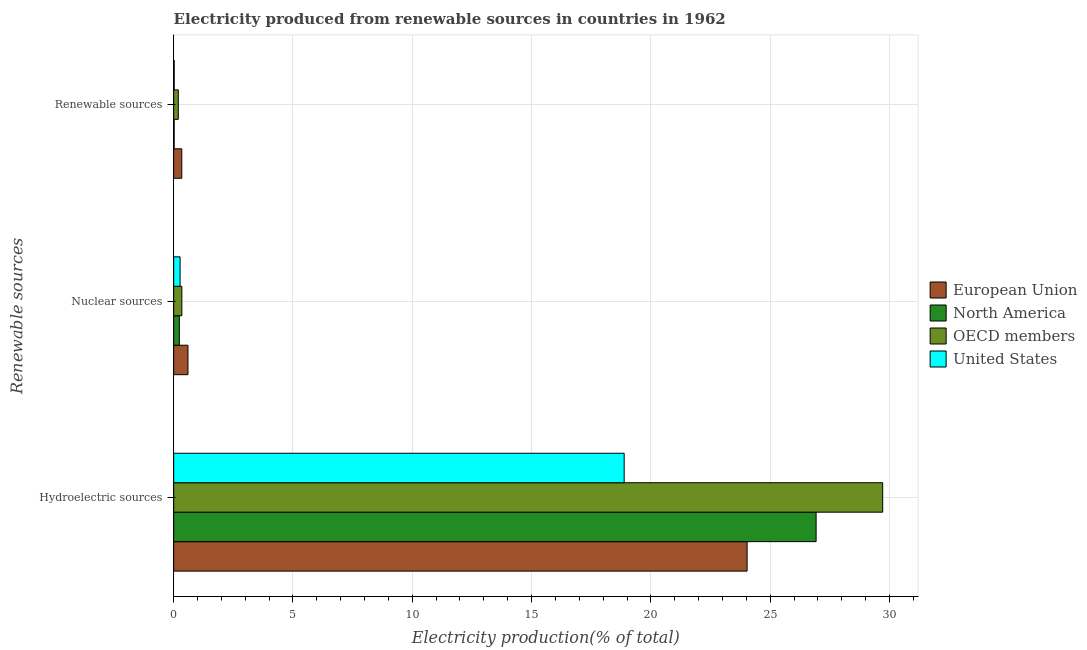How many different coloured bars are there?
Ensure brevity in your answer.  4. How many groups of bars are there?
Your response must be concise. 3. Are the number of bars on each tick of the Y-axis equal?
Your response must be concise. Yes. How many bars are there on the 2nd tick from the top?
Ensure brevity in your answer.  4. What is the label of the 3rd group of bars from the top?
Give a very brief answer. Hydroelectric sources. What is the percentage of electricity produced by hydroelectric sources in OECD members?
Offer a very short reply. 29.72. Across all countries, what is the maximum percentage of electricity produced by hydroelectric sources?
Your answer should be compact. 29.72. Across all countries, what is the minimum percentage of electricity produced by renewable sources?
Offer a terse response. 0.02. In which country was the percentage of electricity produced by nuclear sources maximum?
Offer a very short reply. European Union. What is the total percentage of electricity produced by renewable sources in the graph?
Offer a very short reply. 0.58. What is the difference between the percentage of electricity produced by hydroelectric sources in North America and that in OECD members?
Your response must be concise. -2.79. What is the difference between the percentage of electricity produced by hydroelectric sources in OECD members and the percentage of electricity produced by nuclear sources in European Union?
Give a very brief answer. 29.12. What is the average percentage of electricity produced by hydroelectric sources per country?
Provide a short and direct response. 24.89. What is the difference between the percentage of electricity produced by hydroelectric sources and percentage of electricity produced by renewable sources in European Union?
Your response must be concise. 23.69. What is the ratio of the percentage of electricity produced by nuclear sources in OECD members to that in European Union?
Make the answer very short. 0.57. What is the difference between the highest and the second highest percentage of electricity produced by nuclear sources?
Keep it short and to the point. 0.26. What is the difference between the highest and the lowest percentage of electricity produced by hydroelectric sources?
Make the answer very short. 10.83. In how many countries, is the percentage of electricity produced by hydroelectric sources greater than the average percentage of electricity produced by hydroelectric sources taken over all countries?
Give a very brief answer. 2. Is the sum of the percentage of electricity produced by nuclear sources in United States and North America greater than the maximum percentage of electricity produced by hydroelectric sources across all countries?
Your answer should be very brief. No. What does the 3rd bar from the top in Hydroelectric sources represents?
Offer a very short reply. North America. What does the 2nd bar from the bottom in Nuclear sources represents?
Keep it short and to the point. North America. Is it the case that in every country, the sum of the percentage of electricity produced by hydroelectric sources and percentage of electricity produced by nuclear sources is greater than the percentage of electricity produced by renewable sources?
Give a very brief answer. Yes. Are all the bars in the graph horizontal?
Your answer should be very brief. Yes. Does the graph contain grids?
Give a very brief answer. Yes. Where does the legend appear in the graph?
Ensure brevity in your answer.  Center right. How are the legend labels stacked?
Your answer should be very brief. Vertical. What is the title of the graph?
Your response must be concise. Electricity produced from renewable sources in countries in 1962. Does "Libya" appear as one of the legend labels in the graph?
Provide a short and direct response. No. What is the label or title of the X-axis?
Your answer should be compact. Electricity production(% of total). What is the label or title of the Y-axis?
Ensure brevity in your answer.  Renewable sources. What is the Electricity production(% of total) of European Union in Hydroelectric sources?
Offer a terse response. 24.03. What is the Electricity production(% of total) of North America in Hydroelectric sources?
Your answer should be compact. 26.93. What is the Electricity production(% of total) of OECD members in Hydroelectric sources?
Provide a short and direct response. 29.72. What is the Electricity production(% of total) in United States in Hydroelectric sources?
Ensure brevity in your answer.  18.88. What is the Electricity production(% of total) of European Union in Nuclear sources?
Keep it short and to the point. 0.6. What is the Electricity production(% of total) of North America in Nuclear sources?
Offer a terse response. 0.24. What is the Electricity production(% of total) in OECD members in Nuclear sources?
Offer a very short reply. 0.34. What is the Electricity production(% of total) in United States in Nuclear sources?
Offer a very short reply. 0.27. What is the Electricity production(% of total) in European Union in Renewable sources?
Ensure brevity in your answer.  0.34. What is the Electricity production(% of total) in North America in Renewable sources?
Keep it short and to the point. 0.02. What is the Electricity production(% of total) of OECD members in Renewable sources?
Offer a very short reply. 0.19. What is the Electricity production(% of total) of United States in Renewable sources?
Offer a very short reply. 0.02. Across all Renewable sources, what is the maximum Electricity production(% of total) in European Union?
Your answer should be very brief. 24.03. Across all Renewable sources, what is the maximum Electricity production(% of total) of North America?
Offer a very short reply. 26.93. Across all Renewable sources, what is the maximum Electricity production(% of total) in OECD members?
Your answer should be very brief. 29.72. Across all Renewable sources, what is the maximum Electricity production(% of total) of United States?
Offer a terse response. 18.88. Across all Renewable sources, what is the minimum Electricity production(% of total) of European Union?
Offer a terse response. 0.34. Across all Renewable sources, what is the minimum Electricity production(% of total) in North America?
Your response must be concise. 0.02. Across all Renewable sources, what is the minimum Electricity production(% of total) in OECD members?
Make the answer very short. 0.19. Across all Renewable sources, what is the minimum Electricity production(% of total) of United States?
Your answer should be very brief. 0.02. What is the total Electricity production(% of total) of European Union in the graph?
Keep it short and to the point. 24.97. What is the total Electricity production(% of total) of North America in the graph?
Make the answer very short. 27.18. What is the total Electricity production(% of total) of OECD members in the graph?
Offer a very short reply. 30.25. What is the total Electricity production(% of total) of United States in the graph?
Offer a very short reply. 19.17. What is the difference between the Electricity production(% of total) in European Union in Hydroelectric sources and that in Nuclear sources?
Keep it short and to the point. 23.43. What is the difference between the Electricity production(% of total) in North America in Hydroelectric sources and that in Nuclear sources?
Give a very brief answer. 26.69. What is the difference between the Electricity production(% of total) of OECD members in Hydroelectric sources and that in Nuclear sources?
Your answer should be very brief. 29.37. What is the difference between the Electricity production(% of total) in United States in Hydroelectric sources and that in Nuclear sources?
Provide a short and direct response. 18.61. What is the difference between the Electricity production(% of total) in European Union in Hydroelectric sources and that in Renewable sources?
Your answer should be very brief. 23.69. What is the difference between the Electricity production(% of total) in North America in Hydroelectric sources and that in Renewable sources?
Your response must be concise. 26.91. What is the difference between the Electricity production(% of total) of OECD members in Hydroelectric sources and that in Renewable sources?
Provide a succinct answer. 29.52. What is the difference between the Electricity production(% of total) of United States in Hydroelectric sources and that in Renewable sources?
Your answer should be very brief. 18.86. What is the difference between the Electricity production(% of total) in European Union in Nuclear sources and that in Renewable sources?
Your response must be concise. 0.26. What is the difference between the Electricity production(% of total) of North America in Nuclear sources and that in Renewable sources?
Offer a terse response. 0.22. What is the difference between the Electricity production(% of total) in OECD members in Nuclear sources and that in Renewable sources?
Offer a terse response. 0.15. What is the difference between the Electricity production(% of total) of United States in Nuclear sources and that in Renewable sources?
Keep it short and to the point. 0.25. What is the difference between the Electricity production(% of total) in European Union in Hydroelectric sources and the Electricity production(% of total) in North America in Nuclear sources?
Provide a short and direct response. 23.8. What is the difference between the Electricity production(% of total) in European Union in Hydroelectric sources and the Electricity production(% of total) in OECD members in Nuclear sources?
Offer a terse response. 23.69. What is the difference between the Electricity production(% of total) of European Union in Hydroelectric sources and the Electricity production(% of total) of United States in Nuclear sources?
Your answer should be compact. 23.77. What is the difference between the Electricity production(% of total) in North America in Hydroelectric sources and the Electricity production(% of total) in OECD members in Nuclear sources?
Your answer should be very brief. 26.58. What is the difference between the Electricity production(% of total) in North America in Hydroelectric sources and the Electricity production(% of total) in United States in Nuclear sources?
Your response must be concise. 26.66. What is the difference between the Electricity production(% of total) of OECD members in Hydroelectric sources and the Electricity production(% of total) of United States in Nuclear sources?
Give a very brief answer. 29.45. What is the difference between the Electricity production(% of total) of European Union in Hydroelectric sources and the Electricity production(% of total) of North America in Renewable sources?
Offer a terse response. 24.01. What is the difference between the Electricity production(% of total) of European Union in Hydroelectric sources and the Electricity production(% of total) of OECD members in Renewable sources?
Offer a terse response. 23.84. What is the difference between the Electricity production(% of total) in European Union in Hydroelectric sources and the Electricity production(% of total) in United States in Renewable sources?
Make the answer very short. 24.01. What is the difference between the Electricity production(% of total) in North America in Hydroelectric sources and the Electricity production(% of total) in OECD members in Renewable sources?
Your response must be concise. 26.73. What is the difference between the Electricity production(% of total) in North America in Hydroelectric sources and the Electricity production(% of total) in United States in Renewable sources?
Ensure brevity in your answer.  26.9. What is the difference between the Electricity production(% of total) in OECD members in Hydroelectric sources and the Electricity production(% of total) in United States in Renewable sources?
Your answer should be compact. 29.69. What is the difference between the Electricity production(% of total) in European Union in Nuclear sources and the Electricity production(% of total) in North America in Renewable sources?
Your response must be concise. 0.58. What is the difference between the Electricity production(% of total) of European Union in Nuclear sources and the Electricity production(% of total) of OECD members in Renewable sources?
Your response must be concise. 0.41. What is the difference between the Electricity production(% of total) of European Union in Nuclear sources and the Electricity production(% of total) of United States in Renewable sources?
Offer a very short reply. 0.58. What is the difference between the Electricity production(% of total) of North America in Nuclear sources and the Electricity production(% of total) of OECD members in Renewable sources?
Provide a short and direct response. 0.04. What is the difference between the Electricity production(% of total) of North America in Nuclear sources and the Electricity production(% of total) of United States in Renewable sources?
Your answer should be compact. 0.21. What is the difference between the Electricity production(% of total) of OECD members in Nuclear sources and the Electricity production(% of total) of United States in Renewable sources?
Offer a very short reply. 0.32. What is the average Electricity production(% of total) in European Union per Renewable sources?
Provide a short and direct response. 8.32. What is the average Electricity production(% of total) of North America per Renewable sources?
Make the answer very short. 9.06. What is the average Electricity production(% of total) of OECD members per Renewable sources?
Provide a succinct answer. 10.08. What is the average Electricity production(% of total) of United States per Renewable sources?
Offer a very short reply. 6.39. What is the difference between the Electricity production(% of total) of European Union and Electricity production(% of total) of North America in Hydroelectric sources?
Give a very brief answer. -2.89. What is the difference between the Electricity production(% of total) in European Union and Electricity production(% of total) in OECD members in Hydroelectric sources?
Ensure brevity in your answer.  -5.68. What is the difference between the Electricity production(% of total) in European Union and Electricity production(% of total) in United States in Hydroelectric sources?
Your response must be concise. 5.15. What is the difference between the Electricity production(% of total) of North America and Electricity production(% of total) of OECD members in Hydroelectric sources?
Your answer should be compact. -2.79. What is the difference between the Electricity production(% of total) in North America and Electricity production(% of total) in United States in Hydroelectric sources?
Give a very brief answer. 8.04. What is the difference between the Electricity production(% of total) in OECD members and Electricity production(% of total) in United States in Hydroelectric sources?
Provide a succinct answer. 10.83. What is the difference between the Electricity production(% of total) of European Union and Electricity production(% of total) of North America in Nuclear sources?
Your response must be concise. 0.36. What is the difference between the Electricity production(% of total) in European Union and Electricity production(% of total) in OECD members in Nuclear sources?
Keep it short and to the point. 0.26. What is the difference between the Electricity production(% of total) in European Union and Electricity production(% of total) in United States in Nuclear sources?
Provide a short and direct response. 0.33. What is the difference between the Electricity production(% of total) in North America and Electricity production(% of total) in OECD members in Nuclear sources?
Offer a terse response. -0.11. What is the difference between the Electricity production(% of total) of North America and Electricity production(% of total) of United States in Nuclear sources?
Your answer should be very brief. -0.03. What is the difference between the Electricity production(% of total) in OECD members and Electricity production(% of total) in United States in Nuclear sources?
Give a very brief answer. 0.07. What is the difference between the Electricity production(% of total) of European Union and Electricity production(% of total) of North America in Renewable sources?
Make the answer very short. 0.32. What is the difference between the Electricity production(% of total) in European Union and Electricity production(% of total) in OECD members in Renewable sources?
Your answer should be very brief. 0.15. What is the difference between the Electricity production(% of total) of European Union and Electricity production(% of total) of United States in Renewable sources?
Your response must be concise. 0.32. What is the difference between the Electricity production(% of total) in North America and Electricity production(% of total) in OECD members in Renewable sources?
Your response must be concise. -0.17. What is the difference between the Electricity production(% of total) in North America and Electricity production(% of total) in United States in Renewable sources?
Your answer should be compact. -0. What is the difference between the Electricity production(% of total) in OECD members and Electricity production(% of total) in United States in Renewable sources?
Give a very brief answer. 0.17. What is the ratio of the Electricity production(% of total) in European Union in Hydroelectric sources to that in Nuclear sources?
Your response must be concise. 40.13. What is the ratio of the Electricity production(% of total) in North America in Hydroelectric sources to that in Nuclear sources?
Your response must be concise. 113.49. What is the ratio of the Electricity production(% of total) in OECD members in Hydroelectric sources to that in Nuclear sources?
Give a very brief answer. 86.7. What is the ratio of the Electricity production(% of total) of United States in Hydroelectric sources to that in Nuclear sources?
Make the answer very short. 70.27. What is the ratio of the Electricity production(% of total) in European Union in Hydroelectric sources to that in Renewable sources?
Make the answer very short. 70.73. What is the ratio of the Electricity production(% of total) in North America in Hydroelectric sources to that in Renewable sources?
Offer a terse response. 1338.16. What is the ratio of the Electricity production(% of total) in OECD members in Hydroelectric sources to that in Renewable sources?
Your answer should be compact. 153.58. What is the ratio of the Electricity production(% of total) of United States in Hydroelectric sources to that in Renewable sources?
Your response must be concise. 828.59. What is the ratio of the Electricity production(% of total) in European Union in Nuclear sources to that in Renewable sources?
Your answer should be very brief. 1.76. What is the ratio of the Electricity production(% of total) in North America in Nuclear sources to that in Renewable sources?
Your response must be concise. 11.79. What is the ratio of the Electricity production(% of total) in OECD members in Nuclear sources to that in Renewable sources?
Keep it short and to the point. 1.77. What is the ratio of the Electricity production(% of total) in United States in Nuclear sources to that in Renewable sources?
Give a very brief answer. 11.79. What is the difference between the highest and the second highest Electricity production(% of total) of European Union?
Your response must be concise. 23.43. What is the difference between the highest and the second highest Electricity production(% of total) of North America?
Keep it short and to the point. 26.69. What is the difference between the highest and the second highest Electricity production(% of total) of OECD members?
Keep it short and to the point. 29.37. What is the difference between the highest and the second highest Electricity production(% of total) in United States?
Provide a short and direct response. 18.61. What is the difference between the highest and the lowest Electricity production(% of total) of European Union?
Offer a very short reply. 23.69. What is the difference between the highest and the lowest Electricity production(% of total) in North America?
Provide a short and direct response. 26.91. What is the difference between the highest and the lowest Electricity production(% of total) in OECD members?
Keep it short and to the point. 29.52. What is the difference between the highest and the lowest Electricity production(% of total) in United States?
Make the answer very short. 18.86. 